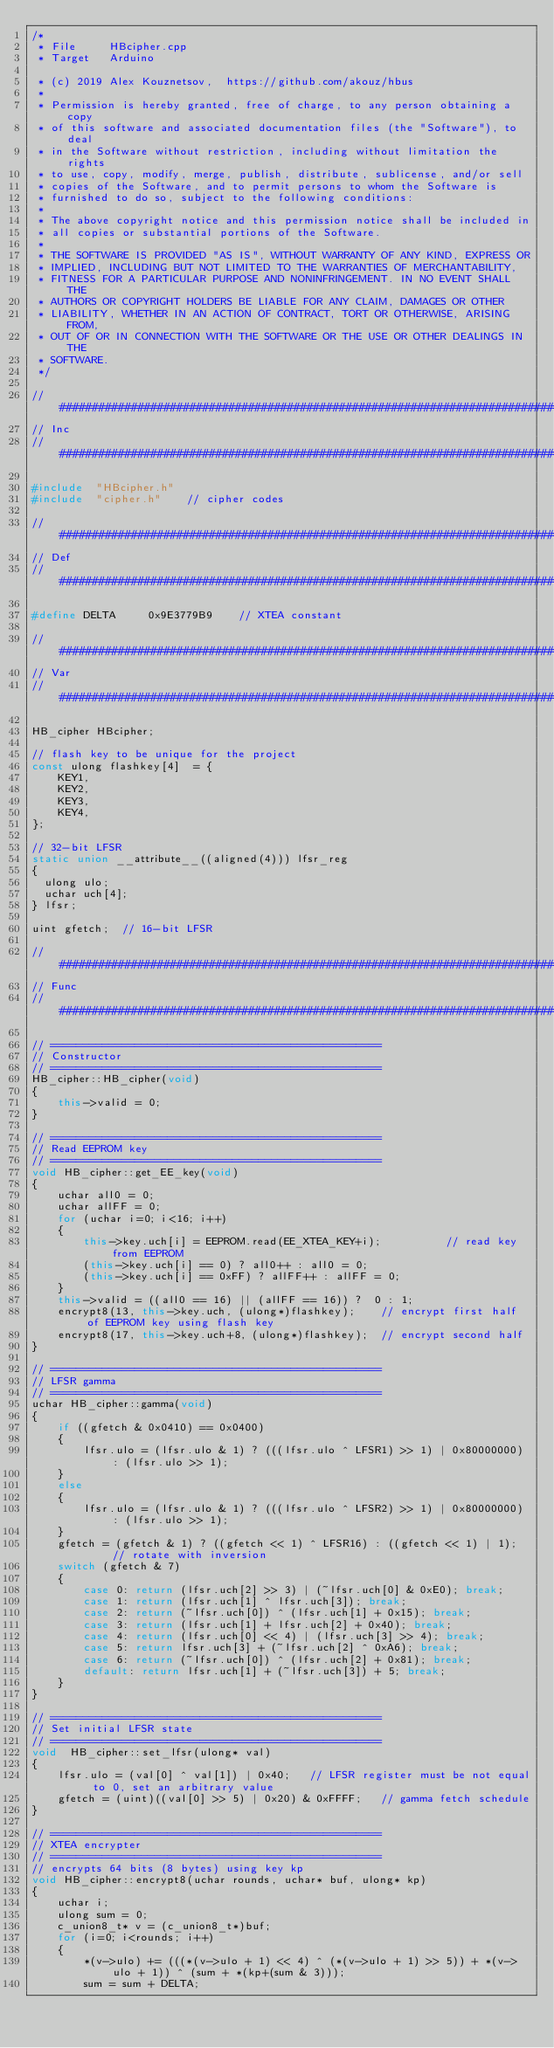<code> <loc_0><loc_0><loc_500><loc_500><_C++_>/*
 * File     HBcipher.cpp
 * Target   Arduino 

 * (c) 2019 Alex Kouznetsov,  https://github.com/akouz/hbus
 *
 * Permission is hereby granted, free of charge, to any person obtaining a copy
 * of this software and associated documentation files (the "Software"), to deal
 * in the Software without restriction, including without limitation the rights
 * to use, copy, modify, merge, publish, distribute, sublicense, and/or sell
 * copies of the Software, and to permit persons to whom the Software is
 * furnished to do so, subject to the following conditions:
 *
 * The above copyright notice and this permission notice shall be included in
 * all copies or substantial portions of the Software.
 * 
 * THE SOFTWARE IS PROVIDED "AS IS", WITHOUT WARRANTY OF ANY KIND, EXPRESS OR
 * IMPLIED, INCLUDING BUT NOT LIMITED TO THE WARRANTIES OF MERCHANTABILITY,
 * FITNESS FOR A PARTICULAR PURPOSE AND NONINFRINGEMENT. IN NO EVENT SHALL THE
 * AUTHORS OR COPYRIGHT HOLDERS BE LIABLE FOR ANY CLAIM, DAMAGES OR OTHER
 * LIABILITY, WHETHER IN AN ACTION OF CONTRACT, TORT OR OTHERWISE, ARISING FROM,
 * OUT OF OR IN CONNECTION WITH THE SOFTWARE OR THE USE OR OTHER DEALINGS IN THE
 * SOFTWARE.
 */

//##############################################################################
// Inc
//##############################################################################

#include  "HBcipher.h"
#include  "cipher.h"    // cipher codes

//##############################################################################
// Def
//##############################################################################

#define DELTA     0x9E3779B9    // XTEA constant

//##############################################################################
// Var
//##############################################################################

HB_cipher HBcipher;

// flash key to be unique for the project
const ulong flashkey[4]  = { 
    KEY1,
    KEY2,
    KEY3,
    KEY4,
};

// 32-bit LFSR
static union __attribute__((aligned(4))) lfsr_reg
{
  ulong ulo;
  uchar uch[4];
} lfsr;

uint gfetch;  // 16-bit LFSR

//##############################################################################
// Func
//##############################################################################

// ===================================================
// Constructor
// ===================================================
HB_cipher::HB_cipher(void)
{
    this->valid = 0;
}

// ===================================================
// Read EEPROM key
// ===================================================
void HB_cipher::get_EE_key(void)
{
    uchar all0 = 0;
    uchar allFF = 0;
    for (uchar i=0; i<16; i++)
    {
        this->key.uch[i] = EEPROM.read(EE_XTEA_KEY+i);          // read key from EEPROM
        (this->key.uch[i] == 0) ? all0++ : all0 = 0;
        (this->key.uch[i] == 0xFF) ? allFF++ : allFF = 0;        
    }
    this->valid = ((all0 == 16) || (allFF == 16)) ?  0 : 1; 
    encrypt8(13, this->key.uch, (ulong*)flashkey);    // encrypt first half of EEPROM key using flash key
    encrypt8(17, this->key.uch+8, (ulong*)flashkey);  // encrypt second half
}

// ===================================================
// LFSR gamma
// ===================================================
uchar HB_cipher::gamma(void)
{
    if ((gfetch & 0x0410) == 0x0400)
    {
        lfsr.ulo = (lfsr.ulo & 1) ? (((lfsr.ulo ^ LFSR1) >> 1) | 0x80000000) : (lfsr.ulo >> 1);
    }
    else
    {
        lfsr.ulo = (lfsr.ulo & 1) ? (((lfsr.ulo ^ LFSR2) >> 1) | 0x80000000) : (lfsr.ulo >> 1);
    }
    gfetch = (gfetch & 1) ? ((gfetch << 1) ^ LFSR16) : ((gfetch << 1) | 1);     // rotate with inversion
    switch (gfetch & 7)      
    {
        case 0: return (lfsr.uch[2] >> 3) | (~lfsr.uch[0] & 0xE0); break;
        case 1: return (lfsr.uch[1] ^ lfsr.uch[3]); break;
        case 2: return (~lfsr.uch[0]) ^ (lfsr.uch[1] + 0x15); break;
        case 3: return (lfsr.uch[1] + lfsr.uch[2] + 0x40); break;
        case 4: return (lfsr.uch[0] << 4) | (lfsr.uch[3] >> 4); break;
        case 5: return lfsr.uch[3] + (~lfsr.uch[2] ^ 0xA6); break;
        case 6: return (~lfsr.uch[0]) ^ (lfsr.uch[2] + 0x81); break;
        default: return lfsr.uch[1] + (~lfsr.uch[3]) + 5; break;          
    }   
}

// ===================================================
// Set initial LFSR state
// ===================================================
void  HB_cipher::set_lfsr(ulong* val)
{
    lfsr.ulo = (val[0] ^ val[1]) | 0x40;   // LFSR register must be not equal to 0, set an arbitrary value
    gfetch = (uint)((val[0] >> 5) | 0x20) & 0xFFFF;   // gamma fetch schedule  
}

// ===================================================
// XTEA encrypter
// ===================================================
// encrypts 64 bits (8 bytes) using key kp
void HB_cipher::encrypt8(uchar rounds, uchar* buf, ulong* kp)
{
    uchar i;
    ulong sum = 0;
    c_union8_t* v = (c_union8_t*)buf;
    for (i=0; i<rounds; i++)
    {
        *(v->ulo) += (((*(v->ulo + 1) << 4) ^ (*(v->ulo + 1) >> 5)) + *(v->ulo + 1)) ^ (sum + *(kp+(sum & 3)));
        sum = sum + DELTA;</code> 